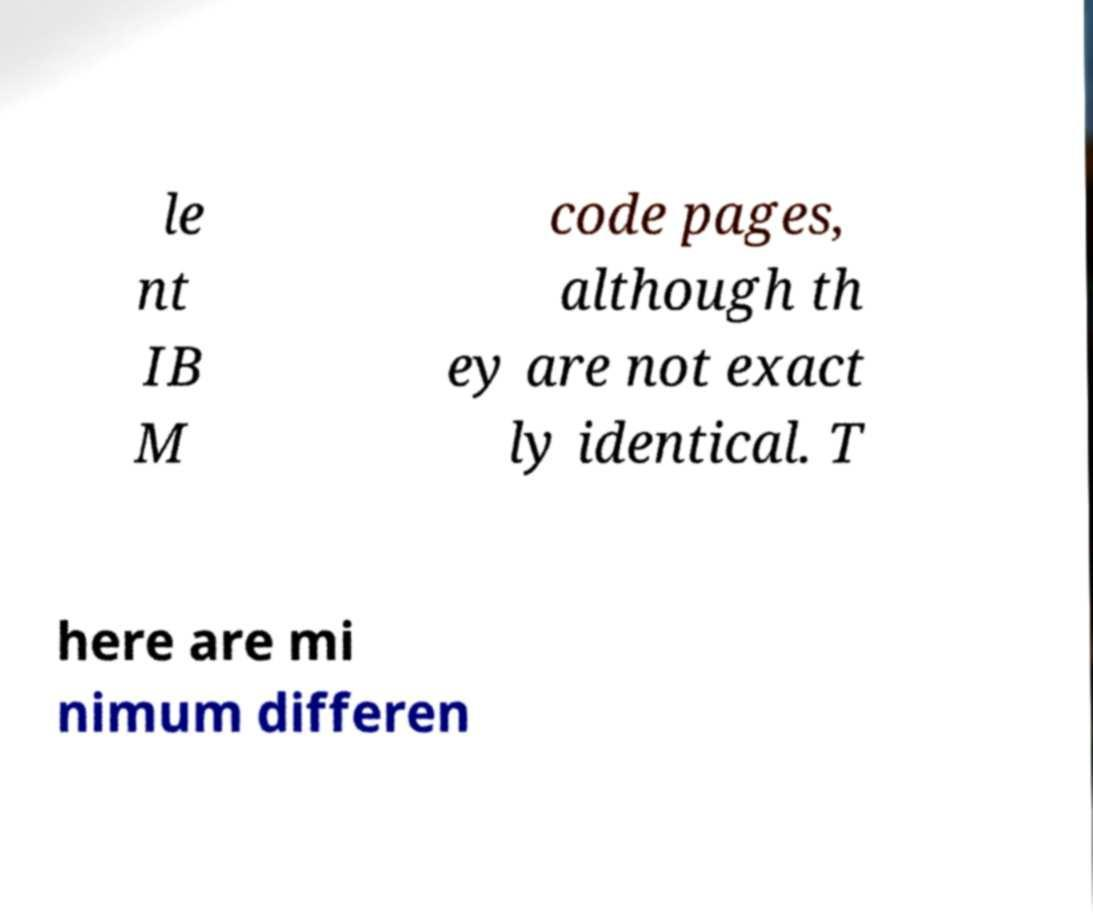There's text embedded in this image that I need extracted. Can you transcribe it verbatim? le nt IB M code pages, although th ey are not exact ly identical. T here are mi nimum differen 